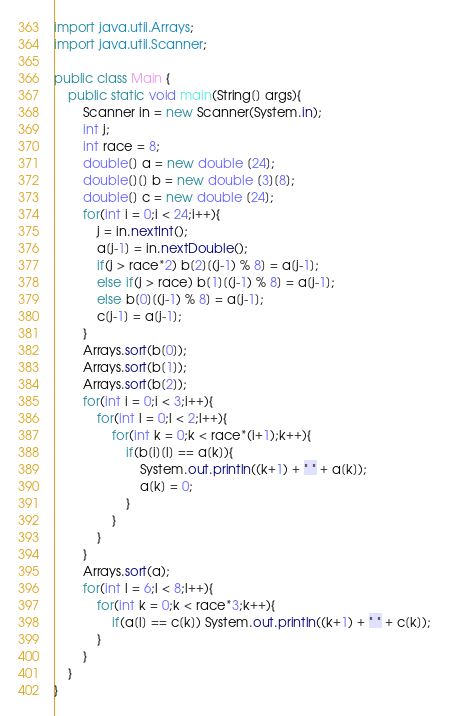Convert code to text. <code><loc_0><loc_0><loc_500><loc_500><_Java_>import java.util.Arrays;
import java.util.Scanner;

public class Main {
	public static void main(String[] args){
		Scanner in = new Scanner(System.in);
		int j;
		int race = 8;
		double[] a = new double [24];
		double[][] b = new double [3][8];
		double[] c = new double [24];
		for(int i = 0;i < 24;i++){
			j = in.nextInt();
			a[j-1] = in.nextDouble();
			if(j > race*2) b[2][(j-1) % 8] = a[j-1];
			else if(j > race) b[1][(j-1) % 8] = a[j-1];
			else b[0][(j-1) % 8] = a[j-1];
			c[j-1] = a[j-1];
		}
		Arrays.sort(b[0]);
		Arrays.sort(b[1]);
		Arrays.sort(b[2]);
		for(int i = 0;i < 3;i++){
			for(int l = 0;l < 2;l++){
				for(int k = 0;k < race*(i+1);k++){
					if(b[i][l] == a[k]){
						System.out.println((k+1) + " " + a[k]);
						a[k] = 0;
					}
				}
			}
		}
		Arrays.sort(a);
		for(int l = 6;l < 8;l++){
			for(int k = 0;k < race*3;k++){	
				if(a[l] == c[k]) System.out.println((k+1) + " " + c[k]);
			}
		}
	}
}</code> 